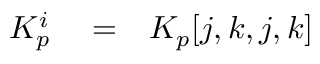<formula> <loc_0><loc_0><loc_500><loc_500>\begin{array} { r l r } { K _ { p } ^ { i } } & = } & { K _ { p } [ j , k , j , k ] } \end{array}</formula> 